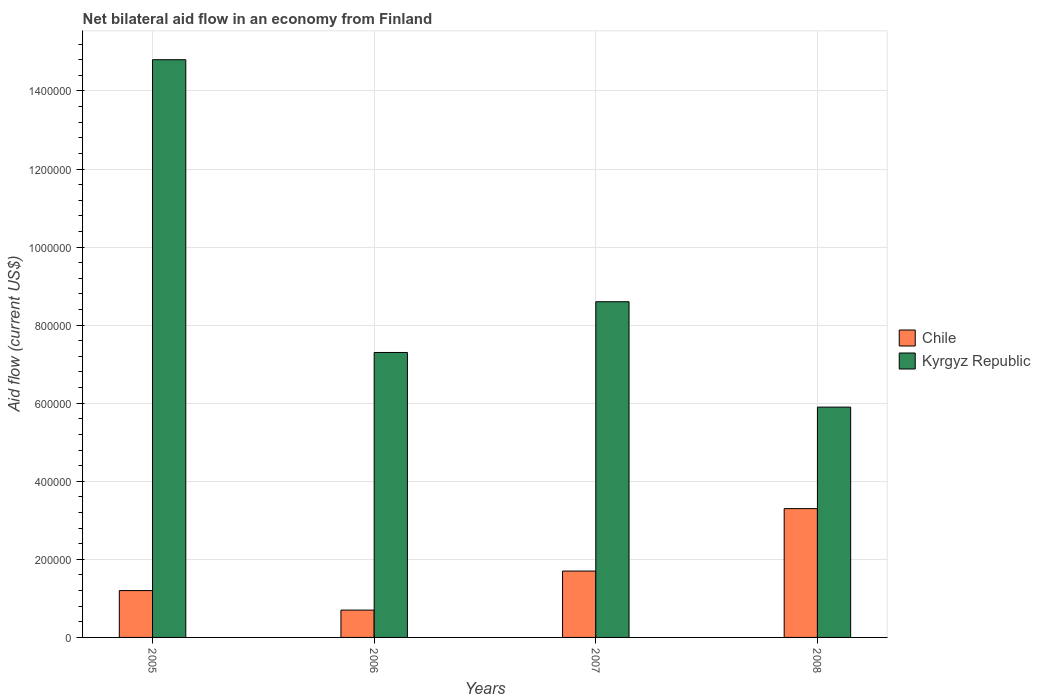How many different coloured bars are there?
Offer a terse response. 2. Are the number of bars per tick equal to the number of legend labels?
Keep it short and to the point. Yes. How many bars are there on the 3rd tick from the left?
Ensure brevity in your answer.  2. What is the label of the 2nd group of bars from the left?
Ensure brevity in your answer.  2006. What is the net bilateral aid flow in Chile in 2007?
Your answer should be very brief. 1.70e+05. Across all years, what is the maximum net bilateral aid flow in Chile?
Your response must be concise. 3.30e+05. Across all years, what is the minimum net bilateral aid flow in Kyrgyz Republic?
Offer a terse response. 5.90e+05. In which year was the net bilateral aid flow in Chile maximum?
Provide a succinct answer. 2008. In which year was the net bilateral aid flow in Chile minimum?
Make the answer very short. 2006. What is the total net bilateral aid flow in Chile in the graph?
Your answer should be very brief. 6.90e+05. What is the average net bilateral aid flow in Chile per year?
Your response must be concise. 1.72e+05. In the year 2006, what is the difference between the net bilateral aid flow in Chile and net bilateral aid flow in Kyrgyz Republic?
Your answer should be very brief. -6.60e+05. What is the ratio of the net bilateral aid flow in Chile in 2005 to that in 2007?
Your answer should be compact. 0.71. Is the net bilateral aid flow in Kyrgyz Republic in 2005 less than that in 2007?
Provide a succinct answer. No. Is the difference between the net bilateral aid flow in Chile in 2005 and 2006 greater than the difference between the net bilateral aid flow in Kyrgyz Republic in 2005 and 2006?
Provide a succinct answer. No. What is the difference between the highest and the second highest net bilateral aid flow in Chile?
Your response must be concise. 1.60e+05. What is the difference between the highest and the lowest net bilateral aid flow in Kyrgyz Republic?
Ensure brevity in your answer.  8.90e+05. In how many years, is the net bilateral aid flow in Kyrgyz Republic greater than the average net bilateral aid flow in Kyrgyz Republic taken over all years?
Your response must be concise. 1. Is the sum of the net bilateral aid flow in Chile in 2005 and 2008 greater than the maximum net bilateral aid flow in Kyrgyz Republic across all years?
Your answer should be compact. No. What does the 1st bar from the left in 2008 represents?
Provide a short and direct response. Chile. What does the 1st bar from the right in 2005 represents?
Offer a terse response. Kyrgyz Republic. Are the values on the major ticks of Y-axis written in scientific E-notation?
Your answer should be compact. No. Does the graph contain any zero values?
Provide a succinct answer. No. Does the graph contain grids?
Keep it short and to the point. Yes. What is the title of the graph?
Your answer should be very brief. Net bilateral aid flow in an economy from Finland. What is the label or title of the X-axis?
Provide a short and direct response. Years. What is the label or title of the Y-axis?
Make the answer very short. Aid flow (current US$). What is the Aid flow (current US$) of Kyrgyz Republic in 2005?
Your response must be concise. 1.48e+06. What is the Aid flow (current US$) of Kyrgyz Republic in 2006?
Offer a very short reply. 7.30e+05. What is the Aid flow (current US$) in Kyrgyz Republic in 2007?
Provide a short and direct response. 8.60e+05. What is the Aid flow (current US$) in Chile in 2008?
Provide a succinct answer. 3.30e+05. What is the Aid flow (current US$) in Kyrgyz Republic in 2008?
Offer a terse response. 5.90e+05. Across all years, what is the maximum Aid flow (current US$) of Kyrgyz Republic?
Ensure brevity in your answer.  1.48e+06. Across all years, what is the minimum Aid flow (current US$) of Chile?
Offer a terse response. 7.00e+04. Across all years, what is the minimum Aid flow (current US$) in Kyrgyz Republic?
Provide a short and direct response. 5.90e+05. What is the total Aid flow (current US$) in Chile in the graph?
Provide a short and direct response. 6.90e+05. What is the total Aid flow (current US$) in Kyrgyz Republic in the graph?
Provide a succinct answer. 3.66e+06. What is the difference between the Aid flow (current US$) of Kyrgyz Republic in 2005 and that in 2006?
Ensure brevity in your answer.  7.50e+05. What is the difference between the Aid flow (current US$) in Chile in 2005 and that in 2007?
Your response must be concise. -5.00e+04. What is the difference between the Aid flow (current US$) in Kyrgyz Republic in 2005 and that in 2007?
Ensure brevity in your answer.  6.20e+05. What is the difference between the Aid flow (current US$) in Kyrgyz Republic in 2005 and that in 2008?
Give a very brief answer. 8.90e+05. What is the difference between the Aid flow (current US$) in Chile in 2005 and the Aid flow (current US$) in Kyrgyz Republic in 2006?
Your answer should be very brief. -6.10e+05. What is the difference between the Aid flow (current US$) of Chile in 2005 and the Aid flow (current US$) of Kyrgyz Republic in 2007?
Provide a short and direct response. -7.40e+05. What is the difference between the Aid flow (current US$) in Chile in 2005 and the Aid flow (current US$) in Kyrgyz Republic in 2008?
Ensure brevity in your answer.  -4.70e+05. What is the difference between the Aid flow (current US$) in Chile in 2006 and the Aid flow (current US$) in Kyrgyz Republic in 2007?
Your answer should be very brief. -7.90e+05. What is the difference between the Aid flow (current US$) in Chile in 2006 and the Aid flow (current US$) in Kyrgyz Republic in 2008?
Your answer should be compact. -5.20e+05. What is the difference between the Aid flow (current US$) of Chile in 2007 and the Aid flow (current US$) of Kyrgyz Republic in 2008?
Offer a very short reply. -4.20e+05. What is the average Aid flow (current US$) in Chile per year?
Keep it short and to the point. 1.72e+05. What is the average Aid flow (current US$) in Kyrgyz Republic per year?
Offer a terse response. 9.15e+05. In the year 2005, what is the difference between the Aid flow (current US$) of Chile and Aid flow (current US$) of Kyrgyz Republic?
Offer a very short reply. -1.36e+06. In the year 2006, what is the difference between the Aid flow (current US$) in Chile and Aid flow (current US$) in Kyrgyz Republic?
Ensure brevity in your answer.  -6.60e+05. In the year 2007, what is the difference between the Aid flow (current US$) of Chile and Aid flow (current US$) of Kyrgyz Republic?
Your response must be concise. -6.90e+05. In the year 2008, what is the difference between the Aid flow (current US$) of Chile and Aid flow (current US$) of Kyrgyz Republic?
Keep it short and to the point. -2.60e+05. What is the ratio of the Aid flow (current US$) in Chile in 2005 to that in 2006?
Your answer should be very brief. 1.71. What is the ratio of the Aid flow (current US$) in Kyrgyz Republic in 2005 to that in 2006?
Make the answer very short. 2.03. What is the ratio of the Aid flow (current US$) in Chile in 2005 to that in 2007?
Ensure brevity in your answer.  0.71. What is the ratio of the Aid flow (current US$) of Kyrgyz Republic in 2005 to that in 2007?
Make the answer very short. 1.72. What is the ratio of the Aid flow (current US$) in Chile in 2005 to that in 2008?
Your answer should be compact. 0.36. What is the ratio of the Aid flow (current US$) in Kyrgyz Republic in 2005 to that in 2008?
Provide a short and direct response. 2.51. What is the ratio of the Aid flow (current US$) of Chile in 2006 to that in 2007?
Provide a short and direct response. 0.41. What is the ratio of the Aid flow (current US$) in Kyrgyz Republic in 2006 to that in 2007?
Offer a terse response. 0.85. What is the ratio of the Aid flow (current US$) in Chile in 2006 to that in 2008?
Your answer should be very brief. 0.21. What is the ratio of the Aid flow (current US$) in Kyrgyz Republic in 2006 to that in 2008?
Keep it short and to the point. 1.24. What is the ratio of the Aid flow (current US$) in Chile in 2007 to that in 2008?
Provide a short and direct response. 0.52. What is the ratio of the Aid flow (current US$) in Kyrgyz Republic in 2007 to that in 2008?
Offer a terse response. 1.46. What is the difference between the highest and the second highest Aid flow (current US$) of Kyrgyz Republic?
Provide a short and direct response. 6.20e+05. What is the difference between the highest and the lowest Aid flow (current US$) in Chile?
Make the answer very short. 2.60e+05. What is the difference between the highest and the lowest Aid flow (current US$) of Kyrgyz Republic?
Your response must be concise. 8.90e+05. 